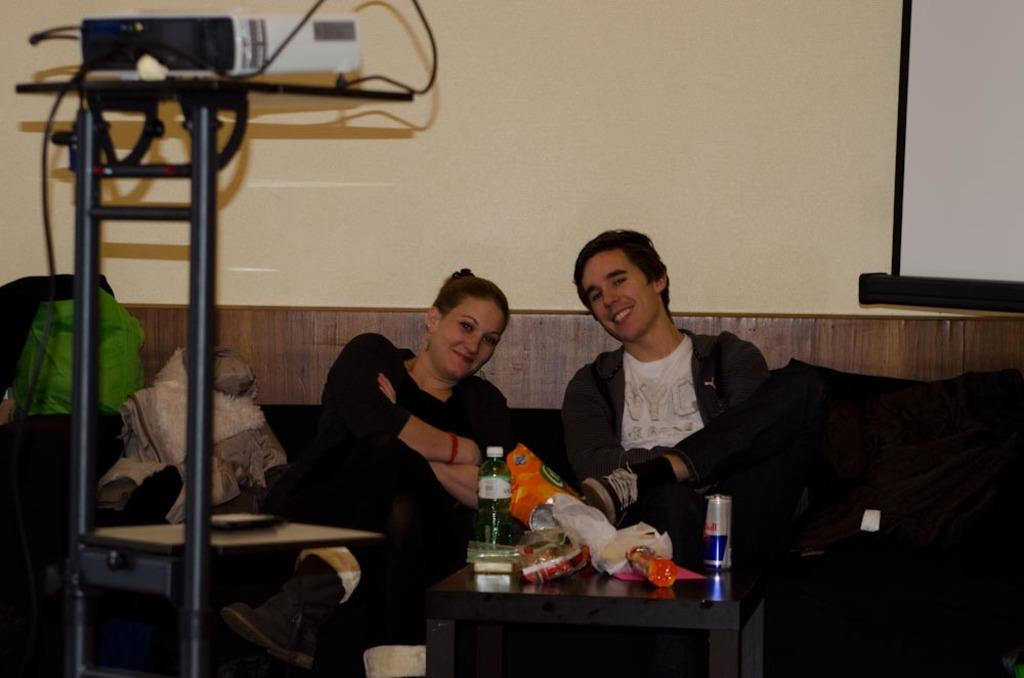How many people are sitting on the sofa in the image? There are two people sitting on the sofa in the image. What is on the table in the image? There is a bottle and covers on the table in the image. What device is used for displaying images or videos in the image? There is a projector with a stand in the image. What item might be used for carrying personal belongings in the image? There is a bag present in the image. What type of operation is being performed on the sofa in the image? There is no operation being performed in the image; it shows two people sitting on a sofa. What type of nut is being cracked on the table in the image? There is no nut present in the image; it shows a bottle and covers on the table. 